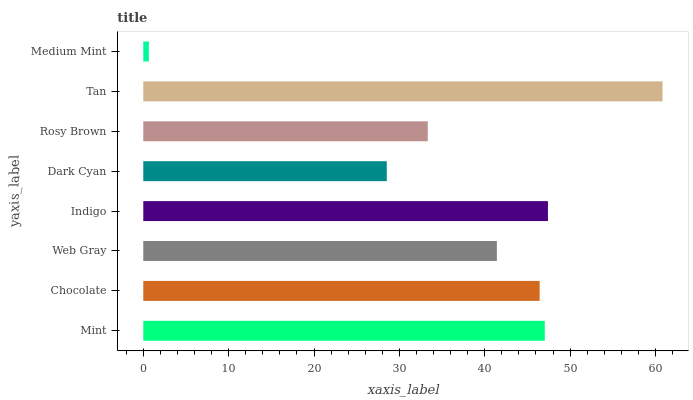Is Medium Mint the minimum?
Answer yes or no. Yes. Is Tan the maximum?
Answer yes or no. Yes. Is Chocolate the minimum?
Answer yes or no. No. Is Chocolate the maximum?
Answer yes or no. No. Is Mint greater than Chocolate?
Answer yes or no. Yes. Is Chocolate less than Mint?
Answer yes or no. Yes. Is Chocolate greater than Mint?
Answer yes or no. No. Is Mint less than Chocolate?
Answer yes or no. No. Is Chocolate the high median?
Answer yes or no. Yes. Is Web Gray the low median?
Answer yes or no. Yes. Is Tan the high median?
Answer yes or no. No. Is Mint the low median?
Answer yes or no. No. 